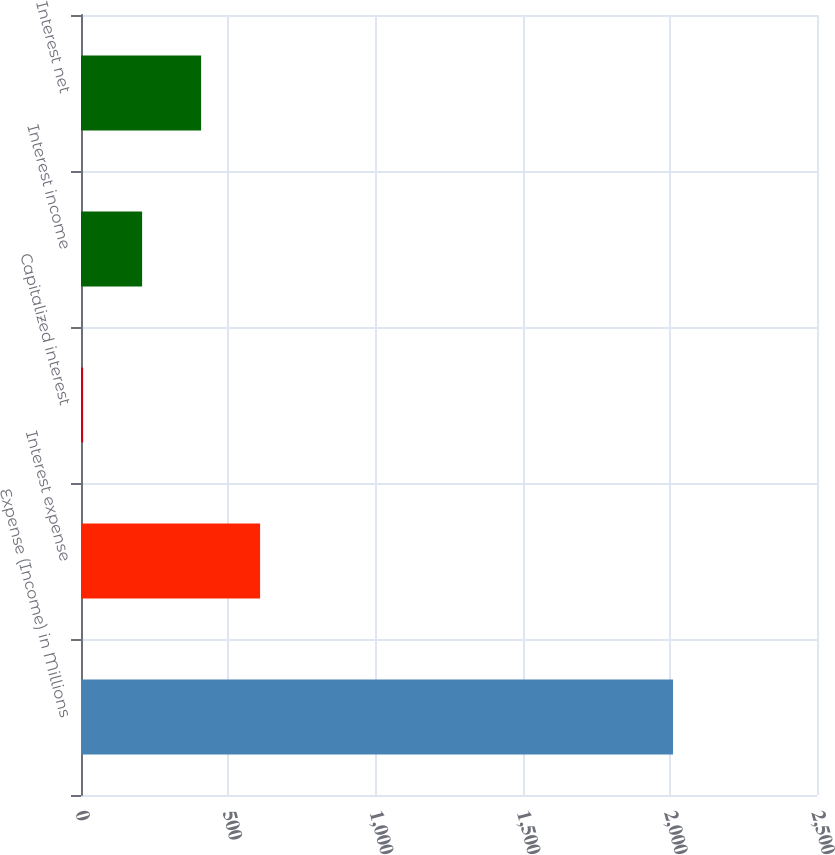<chart> <loc_0><loc_0><loc_500><loc_500><bar_chart><fcel>Expense (Income) in Millions<fcel>Interest expense<fcel>Capitalized interest<fcel>Interest income<fcel>Interest net<nl><fcel>2011<fcel>608.34<fcel>7.2<fcel>207.58<fcel>407.96<nl></chart> 